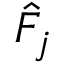Convert formula to latex. <formula><loc_0><loc_0><loc_500><loc_500>\hat { F } _ { j }</formula> 